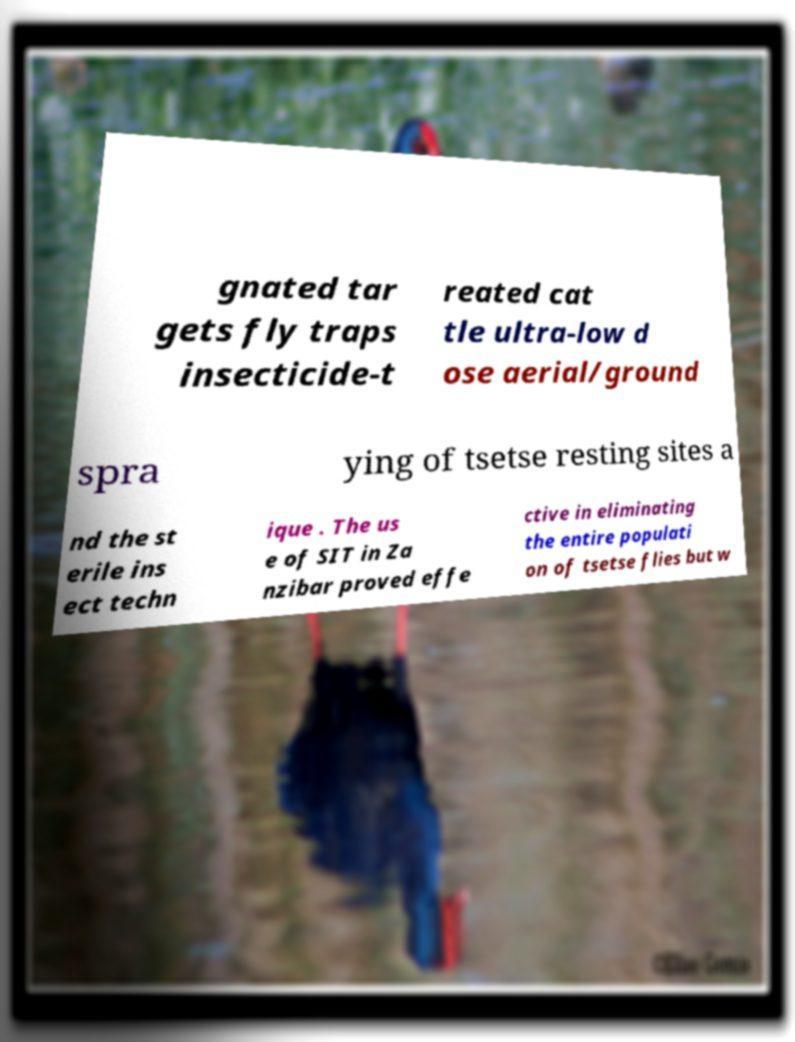For documentation purposes, I need the text within this image transcribed. Could you provide that? gnated tar gets fly traps insecticide-t reated cat tle ultra-low d ose aerial/ground spra ying of tsetse resting sites a nd the st erile ins ect techn ique . The us e of SIT in Za nzibar proved effe ctive in eliminating the entire populati on of tsetse flies but w 